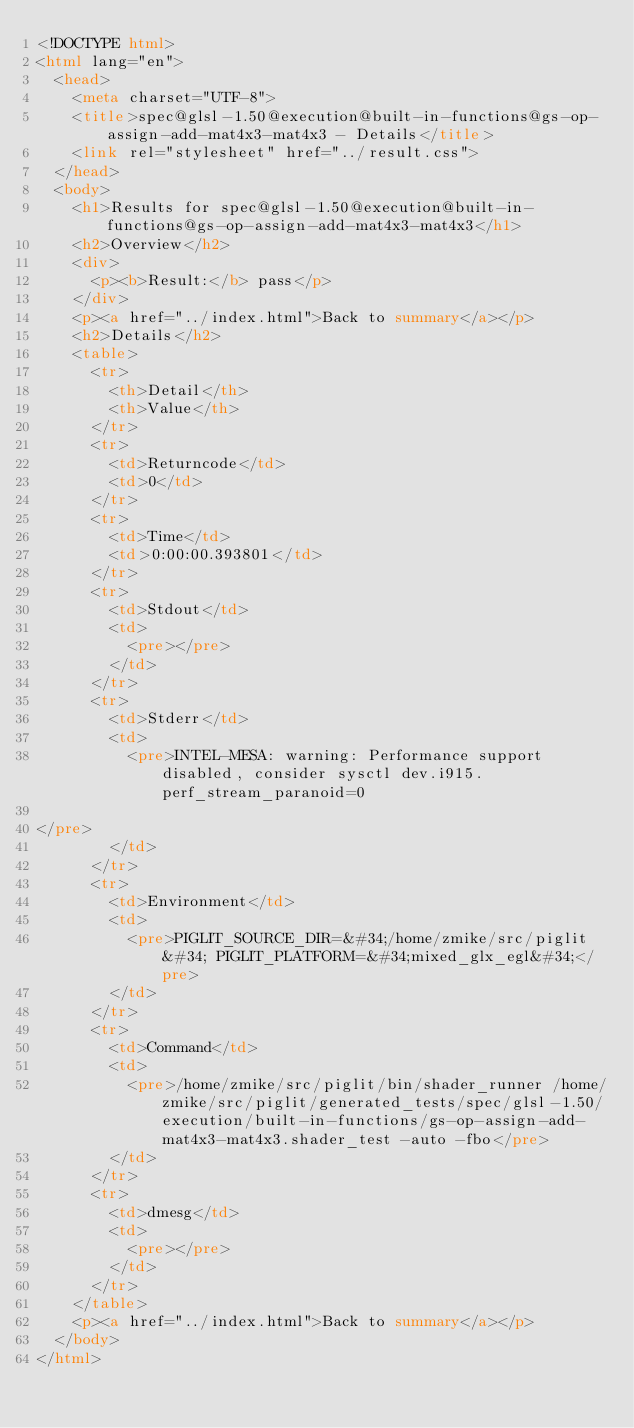<code> <loc_0><loc_0><loc_500><loc_500><_HTML_><!DOCTYPE html>
<html lang="en">
  <head>
    <meta charset="UTF-8">
    <title>spec@glsl-1.50@execution@built-in-functions@gs-op-assign-add-mat4x3-mat4x3 - Details</title>
    <link rel="stylesheet" href="../result.css">
  </head>
  <body>
    <h1>Results for spec@glsl-1.50@execution@built-in-functions@gs-op-assign-add-mat4x3-mat4x3</h1>
    <h2>Overview</h2>
    <div>
      <p><b>Result:</b> pass</p>
    </div>
    <p><a href="../index.html">Back to summary</a></p>
    <h2>Details</h2>
    <table>
      <tr>
        <th>Detail</th>
        <th>Value</th>
      </tr>
      <tr>
        <td>Returncode</td>
        <td>0</td>
      </tr>
      <tr>
        <td>Time</td>
        <td>0:00:00.393801</td>
      </tr>
      <tr>
        <td>Stdout</td>
        <td>
          <pre></pre>
        </td>
      </tr>
      <tr>
        <td>Stderr</td>
        <td>
          <pre>INTEL-MESA: warning: Performance support disabled, consider sysctl dev.i915.perf_stream_paranoid=0

</pre>
        </td>
      </tr>
      <tr>
        <td>Environment</td>
        <td>
          <pre>PIGLIT_SOURCE_DIR=&#34;/home/zmike/src/piglit&#34; PIGLIT_PLATFORM=&#34;mixed_glx_egl&#34;</pre>
        </td>
      </tr>
      <tr>
        <td>Command</td>
        <td>
          <pre>/home/zmike/src/piglit/bin/shader_runner /home/zmike/src/piglit/generated_tests/spec/glsl-1.50/execution/built-in-functions/gs-op-assign-add-mat4x3-mat4x3.shader_test -auto -fbo</pre>
        </td>
      </tr>
      <tr>
        <td>dmesg</td>
        <td>
          <pre></pre>
        </td>
      </tr>
    </table>
    <p><a href="../index.html">Back to summary</a></p>
  </body>
</html>
</code> 